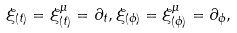<formula> <loc_0><loc_0><loc_500><loc_500>\xi _ { ( t ) } = \xi _ { ( t ) } ^ { \mu } = \partial _ { t } , \xi _ { ( \phi ) } = \xi _ { ( \phi ) } ^ { \mu } = \partial _ { \phi } ,</formula> 